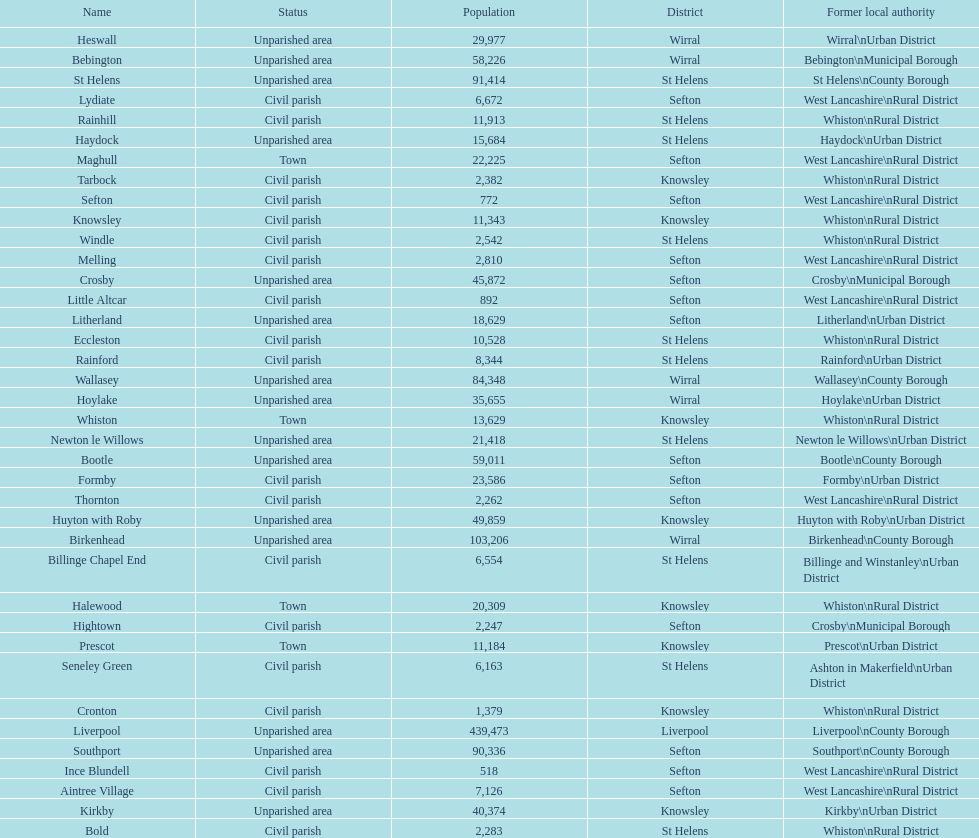How many people live in the bold civil parish? 2,283. 